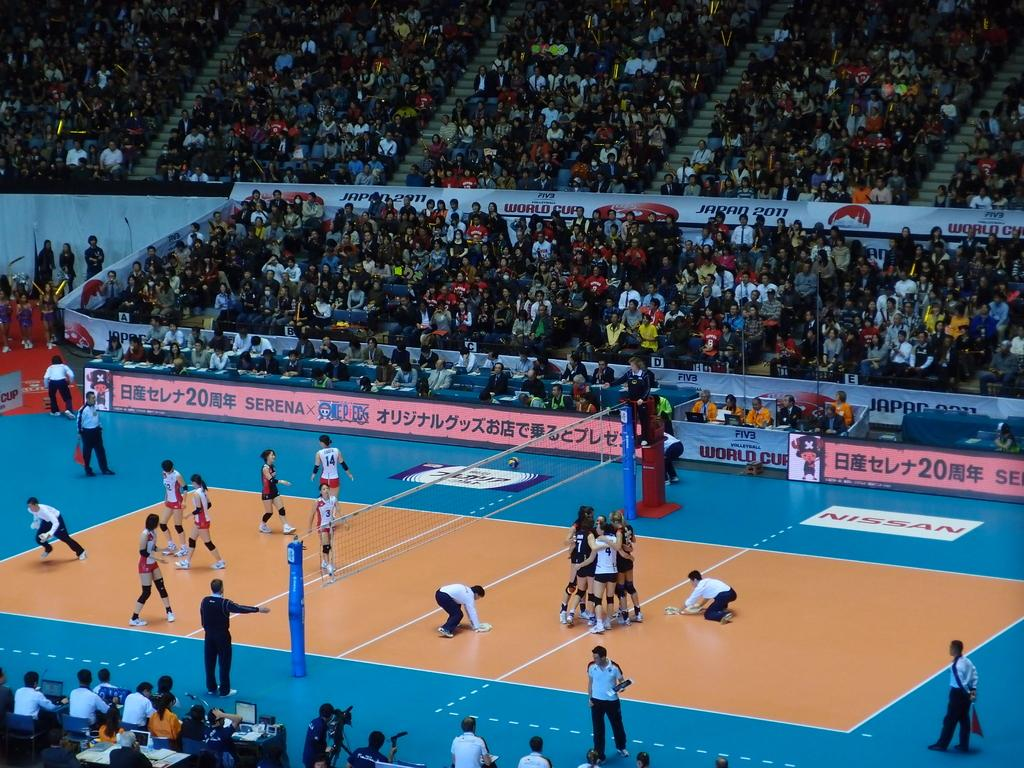<image>
Give a short and clear explanation of the subsequent image. The Volleyball World Cup shows two teams on the court with players #7, 4, 14, and 3 visible on their jerseys. 